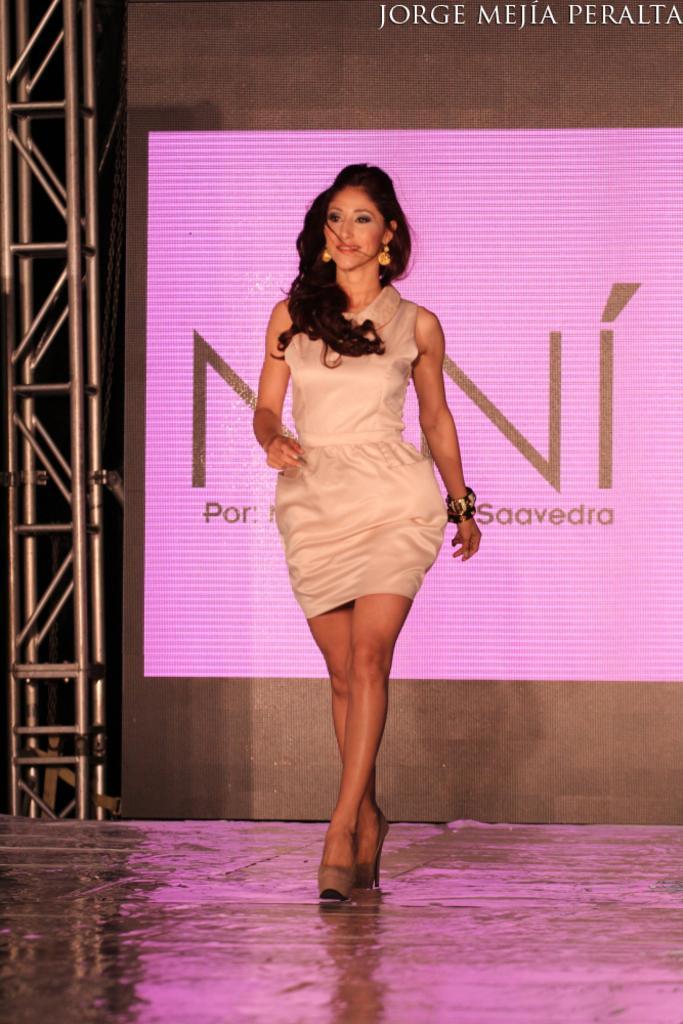Please provide a concise description of this image. In the image we can see there is a woman standing and behind there is a projector screen. 